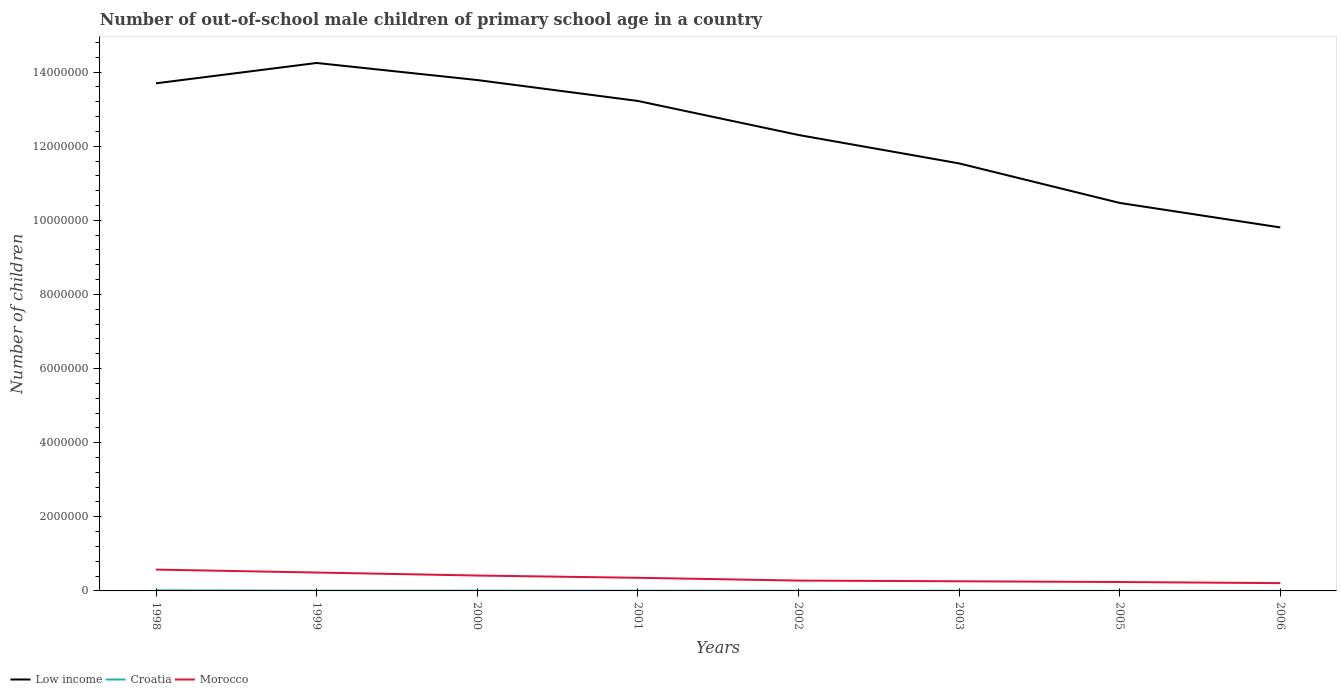How many different coloured lines are there?
Make the answer very short. 3. Does the line corresponding to Croatia intersect with the line corresponding to Low income?
Provide a succinct answer. No. Is the number of lines equal to the number of legend labels?
Offer a terse response. Yes. Across all years, what is the maximum number of out-of-school male children in Croatia?
Provide a short and direct response. 1613. In which year was the number of out-of-school male children in Low income maximum?
Your answer should be compact. 2006. What is the total number of out-of-school male children in Croatia in the graph?
Offer a terse response. 1.18e+04. What is the difference between the highest and the second highest number of out-of-school male children in Morocco?
Your answer should be very brief. 3.65e+05. Is the number of out-of-school male children in Low income strictly greater than the number of out-of-school male children in Croatia over the years?
Offer a terse response. No. How many lines are there?
Your answer should be very brief. 3. How many legend labels are there?
Provide a succinct answer. 3. What is the title of the graph?
Offer a terse response. Number of out-of-school male children of primary school age in a country. What is the label or title of the Y-axis?
Provide a short and direct response. Number of children. What is the Number of children of Low income in 1998?
Keep it short and to the point. 1.37e+07. What is the Number of children of Croatia in 1998?
Offer a very short reply. 1.62e+04. What is the Number of children of Morocco in 1998?
Keep it short and to the point. 5.76e+05. What is the Number of children of Low income in 1999?
Offer a terse response. 1.42e+07. What is the Number of children of Croatia in 1999?
Your answer should be compact. 6765. What is the Number of children in Morocco in 1999?
Offer a very short reply. 4.96e+05. What is the Number of children of Low income in 2000?
Ensure brevity in your answer.  1.38e+07. What is the Number of children of Croatia in 2000?
Give a very brief answer. 6522. What is the Number of children of Morocco in 2000?
Offer a terse response. 4.15e+05. What is the Number of children in Low income in 2001?
Provide a short and direct response. 1.32e+07. What is the Number of children of Croatia in 2001?
Keep it short and to the point. 5639. What is the Number of children in Morocco in 2001?
Ensure brevity in your answer.  3.54e+05. What is the Number of children in Low income in 2002?
Provide a succinct answer. 1.23e+07. What is the Number of children in Croatia in 2002?
Offer a very short reply. 4458. What is the Number of children of Morocco in 2002?
Your answer should be very brief. 2.79e+05. What is the Number of children in Low income in 2003?
Keep it short and to the point. 1.15e+07. What is the Number of children in Croatia in 2003?
Offer a terse response. 3994. What is the Number of children in Morocco in 2003?
Offer a terse response. 2.60e+05. What is the Number of children in Low income in 2005?
Keep it short and to the point. 1.05e+07. What is the Number of children of Croatia in 2005?
Your answer should be very brief. 1768. What is the Number of children of Morocco in 2005?
Ensure brevity in your answer.  2.41e+05. What is the Number of children in Low income in 2006?
Ensure brevity in your answer.  9.81e+06. What is the Number of children of Croatia in 2006?
Give a very brief answer. 1613. What is the Number of children in Morocco in 2006?
Keep it short and to the point. 2.10e+05. Across all years, what is the maximum Number of children in Low income?
Ensure brevity in your answer.  1.42e+07. Across all years, what is the maximum Number of children in Croatia?
Give a very brief answer. 1.62e+04. Across all years, what is the maximum Number of children of Morocco?
Make the answer very short. 5.76e+05. Across all years, what is the minimum Number of children of Low income?
Ensure brevity in your answer.  9.81e+06. Across all years, what is the minimum Number of children of Croatia?
Make the answer very short. 1613. Across all years, what is the minimum Number of children in Morocco?
Give a very brief answer. 2.10e+05. What is the total Number of children of Low income in the graph?
Offer a terse response. 9.91e+07. What is the total Number of children in Croatia in the graph?
Offer a terse response. 4.70e+04. What is the total Number of children of Morocco in the graph?
Provide a succinct answer. 2.83e+06. What is the difference between the Number of children in Low income in 1998 and that in 1999?
Give a very brief answer. -5.49e+05. What is the difference between the Number of children of Croatia in 1998 and that in 1999?
Your answer should be very brief. 9472. What is the difference between the Number of children of Morocco in 1998 and that in 1999?
Make the answer very short. 7.91e+04. What is the difference between the Number of children in Low income in 1998 and that in 2000?
Ensure brevity in your answer.  -8.84e+04. What is the difference between the Number of children of Croatia in 1998 and that in 2000?
Your answer should be very brief. 9715. What is the difference between the Number of children of Morocco in 1998 and that in 2000?
Provide a short and direct response. 1.60e+05. What is the difference between the Number of children of Low income in 1998 and that in 2001?
Give a very brief answer. 4.76e+05. What is the difference between the Number of children of Croatia in 1998 and that in 2001?
Offer a terse response. 1.06e+04. What is the difference between the Number of children in Morocco in 1998 and that in 2001?
Your answer should be very brief. 2.22e+05. What is the difference between the Number of children of Low income in 1998 and that in 2002?
Give a very brief answer. 1.39e+06. What is the difference between the Number of children in Croatia in 1998 and that in 2002?
Ensure brevity in your answer.  1.18e+04. What is the difference between the Number of children of Morocco in 1998 and that in 2002?
Give a very brief answer. 2.96e+05. What is the difference between the Number of children of Low income in 1998 and that in 2003?
Provide a short and direct response. 2.16e+06. What is the difference between the Number of children of Croatia in 1998 and that in 2003?
Your response must be concise. 1.22e+04. What is the difference between the Number of children in Morocco in 1998 and that in 2003?
Offer a very short reply. 3.16e+05. What is the difference between the Number of children in Low income in 1998 and that in 2005?
Provide a succinct answer. 3.23e+06. What is the difference between the Number of children of Croatia in 1998 and that in 2005?
Offer a terse response. 1.45e+04. What is the difference between the Number of children in Morocco in 1998 and that in 2005?
Provide a short and direct response. 3.35e+05. What is the difference between the Number of children of Low income in 1998 and that in 2006?
Your answer should be very brief. 3.89e+06. What is the difference between the Number of children of Croatia in 1998 and that in 2006?
Make the answer very short. 1.46e+04. What is the difference between the Number of children of Morocco in 1998 and that in 2006?
Keep it short and to the point. 3.65e+05. What is the difference between the Number of children in Low income in 1999 and that in 2000?
Keep it short and to the point. 4.61e+05. What is the difference between the Number of children of Croatia in 1999 and that in 2000?
Make the answer very short. 243. What is the difference between the Number of children of Morocco in 1999 and that in 2000?
Ensure brevity in your answer.  8.11e+04. What is the difference between the Number of children of Low income in 1999 and that in 2001?
Your answer should be very brief. 1.02e+06. What is the difference between the Number of children in Croatia in 1999 and that in 2001?
Keep it short and to the point. 1126. What is the difference between the Number of children in Morocco in 1999 and that in 2001?
Ensure brevity in your answer.  1.42e+05. What is the difference between the Number of children in Low income in 1999 and that in 2002?
Offer a terse response. 1.94e+06. What is the difference between the Number of children in Croatia in 1999 and that in 2002?
Offer a terse response. 2307. What is the difference between the Number of children of Morocco in 1999 and that in 2002?
Provide a succinct answer. 2.17e+05. What is the difference between the Number of children in Low income in 1999 and that in 2003?
Your response must be concise. 2.71e+06. What is the difference between the Number of children of Croatia in 1999 and that in 2003?
Your response must be concise. 2771. What is the difference between the Number of children in Morocco in 1999 and that in 2003?
Give a very brief answer. 2.36e+05. What is the difference between the Number of children of Low income in 1999 and that in 2005?
Offer a very short reply. 3.78e+06. What is the difference between the Number of children of Croatia in 1999 and that in 2005?
Offer a very short reply. 4997. What is the difference between the Number of children in Morocco in 1999 and that in 2005?
Offer a very short reply. 2.56e+05. What is the difference between the Number of children in Low income in 1999 and that in 2006?
Your answer should be very brief. 4.44e+06. What is the difference between the Number of children of Croatia in 1999 and that in 2006?
Give a very brief answer. 5152. What is the difference between the Number of children in Morocco in 1999 and that in 2006?
Provide a short and direct response. 2.86e+05. What is the difference between the Number of children of Low income in 2000 and that in 2001?
Give a very brief answer. 5.64e+05. What is the difference between the Number of children in Croatia in 2000 and that in 2001?
Provide a succinct answer. 883. What is the difference between the Number of children of Morocco in 2000 and that in 2001?
Your response must be concise. 6.14e+04. What is the difference between the Number of children in Low income in 2000 and that in 2002?
Your response must be concise. 1.48e+06. What is the difference between the Number of children in Croatia in 2000 and that in 2002?
Give a very brief answer. 2064. What is the difference between the Number of children in Morocco in 2000 and that in 2002?
Your response must be concise. 1.36e+05. What is the difference between the Number of children in Low income in 2000 and that in 2003?
Make the answer very short. 2.25e+06. What is the difference between the Number of children of Croatia in 2000 and that in 2003?
Offer a terse response. 2528. What is the difference between the Number of children in Morocco in 2000 and that in 2003?
Provide a short and direct response. 1.55e+05. What is the difference between the Number of children of Low income in 2000 and that in 2005?
Make the answer very short. 3.32e+06. What is the difference between the Number of children of Croatia in 2000 and that in 2005?
Ensure brevity in your answer.  4754. What is the difference between the Number of children of Morocco in 2000 and that in 2005?
Your answer should be very brief. 1.75e+05. What is the difference between the Number of children in Low income in 2000 and that in 2006?
Make the answer very short. 3.98e+06. What is the difference between the Number of children in Croatia in 2000 and that in 2006?
Provide a succinct answer. 4909. What is the difference between the Number of children in Morocco in 2000 and that in 2006?
Provide a short and direct response. 2.05e+05. What is the difference between the Number of children of Low income in 2001 and that in 2002?
Provide a short and direct response. 9.18e+05. What is the difference between the Number of children of Croatia in 2001 and that in 2002?
Your response must be concise. 1181. What is the difference between the Number of children of Morocco in 2001 and that in 2002?
Provide a short and direct response. 7.48e+04. What is the difference between the Number of children of Low income in 2001 and that in 2003?
Your response must be concise. 1.69e+06. What is the difference between the Number of children in Croatia in 2001 and that in 2003?
Provide a succinct answer. 1645. What is the difference between the Number of children of Morocco in 2001 and that in 2003?
Your response must be concise. 9.40e+04. What is the difference between the Number of children of Low income in 2001 and that in 2005?
Keep it short and to the point. 2.75e+06. What is the difference between the Number of children of Croatia in 2001 and that in 2005?
Provide a short and direct response. 3871. What is the difference between the Number of children in Morocco in 2001 and that in 2005?
Offer a terse response. 1.13e+05. What is the difference between the Number of children in Low income in 2001 and that in 2006?
Provide a short and direct response. 3.41e+06. What is the difference between the Number of children in Croatia in 2001 and that in 2006?
Your answer should be compact. 4026. What is the difference between the Number of children in Morocco in 2001 and that in 2006?
Ensure brevity in your answer.  1.44e+05. What is the difference between the Number of children of Low income in 2002 and that in 2003?
Ensure brevity in your answer.  7.67e+05. What is the difference between the Number of children in Croatia in 2002 and that in 2003?
Your answer should be very brief. 464. What is the difference between the Number of children in Morocco in 2002 and that in 2003?
Ensure brevity in your answer.  1.92e+04. What is the difference between the Number of children in Low income in 2002 and that in 2005?
Your answer should be compact. 1.83e+06. What is the difference between the Number of children of Croatia in 2002 and that in 2005?
Provide a short and direct response. 2690. What is the difference between the Number of children of Morocco in 2002 and that in 2005?
Your answer should be very brief. 3.86e+04. What is the difference between the Number of children in Low income in 2002 and that in 2006?
Your answer should be very brief. 2.50e+06. What is the difference between the Number of children of Croatia in 2002 and that in 2006?
Your response must be concise. 2845. What is the difference between the Number of children of Morocco in 2002 and that in 2006?
Give a very brief answer. 6.87e+04. What is the difference between the Number of children in Low income in 2003 and that in 2005?
Keep it short and to the point. 1.07e+06. What is the difference between the Number of children in Croatia in 2003 and that in 2005?
Give a very brief answer. 2226. What is the difference between the Number of children of Morocco in 2003 and that in 2005?
Provide a succinct answer. 1.94e+04. What is the difference between the Number of children in Low income in 2003 and that in 2006?
Offer a terse response. 1.73e+06. What is the difference between the Number of children of Croatia in 2003 and that in 2006?
Your answer should be very brief. 2381. What is the difference between the Number of children in Morocco in 2003 and that in 2006?
Make the answer very short. 4.95e+04. What is the difference between the Number of children in Low income in 2005 and that in 2006?
Your answer should be compact. 6.61e+05. What is the difference between the Number of children of Croatia in 2005 and that in 2006?
Provide a succinct answer. 155. What is the difference between the Number of children in Morocco in 2005 and that in 2006?
Give a very brief answer. 3.01e+04. What is the difference between the Number of children of Low income in 1998 and the Number of children of Croatia in 1999?
Give a very brief answer. 1.37e+07. What is the difference between the Number of children in Low income in 1998 and the Number of children in Morocco in 1999?
Provide a short and direct response. 1.32e+07. What is the difference between the Number of children in Croatia in 1998 and the Number of children in Morocco in 1999?
Ensure brevity in your answer.  -4.80e+05. What is the difference between the Number of children of Low income in 1998 and the Number of children of Croatia in 2000?
Offer a very short reply. 1.37e+07. What is the difference between the Number of children in Low income in 1998 and the Number of children in Morocco in 2000?
Provide a succinct answer. 1.33e+07. What is the difference between the Number of children in Croatia in 1998 and the Number of children in Morocco in 2000?
Offer a terse response. -3.99e+05. What is the difference between the Number of children of Low income in 1998 and the Number of children of Croatia in 2001?
Ensure brevity in your answer.  1.37e+07. What is the difference between the Number of children in Low income in 1998 and the Number of children in Morocco in 2001?
Offer a very short reply. 1.33e+07. What is the difference between the Number of children in Croatia in 1998 and the Number of children in Morocco in 2001?
Give a very brief answer. -3.38e+05. What is the difference between the Number of children in Low income in 1998 and the Number of children in Croatia in 2002?
Offer a very short reply. 1.37e+07. What is the difference between the Number of children in Low income in 1998 and the Number of children in Morocco in 2002?
Your answer should be compact. 1.34e+07. What is the difference between the Number of children in Croatia in 1998 and the Number of children in Morocco in 2002?
Your answer should be very brief. -2.63e+05. What is the difference between the Number of children in Low income in 1998 and the Number of children in Croatia in 2003?
Your response must be concise. 1.37e+07. What is the difference between the Number of children of Low income in 1998 and the Number of children of Morocco in 2003?
Your answer should be very brief. 1.34e+07. What is the difference between the Number of children of Croatia in 1998 and the Number of children of Morocco in 2003?
Offer a terse response. -2.44e+05. What is the difference between the Number of children of Low income in 1998 and the Number of children of Croatia in 2005?
Offer a very short reply. 1.37e+07. What is the difference between the Number of children of Low income in 1998 and the Number of children of Morocco in 2005?
Offer a very short reply. 1.35e+07. What is the difference between the Number of children in Croatia in 1998 and the Number of children in Morocco in 2005?
Ensure brevity in your answer.  -2.24e+05. What is the difference between the Number of children of Low income in 1998 and the Number of children of Croatia in 2006?
Give a very brief answer. 1.37e+07. What is the difference between the Number of children of Low income in 1998 and the Number of children of Morocco in 2006?
Ensure brevity in your answer.  1.35e+07. What is the difference between the Number of children in Croatia in 1998 and the Number of children in Morocco in 2006?
Give a very brief answer. -1.94e+05. What is the difference between the Number of children in Low income in 1999 and the Number of children in Croatia in 2000?
Give a very brief answer. 1.42e+07. What is the difference between the Number of children in Low income in 1999 and the Number of children in Morocco in 2000?
Provide a succinct answer. 1.38e+07. What is the difference between the Number of children of Croatia in 1999 and the Number of children of Morocco in 2000?
Give a very brief answer. -4.09e+05. What is the difference between the Number of children in Low income in 1999 and the Number of children in Croatia in 2001?
Offer a terse response. 1.42e+07. What is the difference between the Number of children of Low income in 1999 and the Number of children of Morocco in 2001?
Ensure brevity in your answer.  1.39e+07. What is the difference between the Number of children in Croatia in 1999 and the Number of children in Morocco in 2001?
Give a very brief answer. -3.47e+05. What is the difference between the Number of children in Low income in 1999 and the Number of children in Croatia in 2002?
Your answer should be compact. 1.42e+07. What is the difference between the Number of children in Low income in 1999 and the Number of children in Morocco in 2002?
Ensure brevity in your answer.  1.40e+07. What is the difference between the Number of children of Croatia in 1999 and the Number of children of Morocco in 2002?
Keep it short and to the point. -2.72e+05. What is the difference between the Number of children of Low income in 1999 and the Number of children of Croatia in 2003?
Your response must be concise. 1.42e+07. What is the difference between the Number of children in Low income in 1999 and the Number of children in Morocco in 2003?
Give a very brief answer. 1.40e+07. What is the difference between the Number of children in Croatia in 1999 and the Number of children in Morocco in 2003?
Your response must be concise. -2.53e+05. What is the difference between the Number of children in Low income in 1999 and the Number of children in Croatia in 2005?
Make the answer very short. 1.42e+07. What is the difference between the Number of children of Low income in 1999 and the Number of children of Morocco in 2005?
Provide a short and direct response. 1.40e+07. What is the difference between the Number of children of Croatia in 1999 and the Number of children of Morocco in 2005?
Your response must be concise. -2.34e+05. What is the difference between the Number of children in Low income in 1999 and the Number of children in Croatia in 2006?
Make the answer very short. 1.42e+07. What is the difference between the Number of children of Low income in 1999 and the Number of children of Morocco in 2006?
Provide a succinct answer. 1.40e+07. What is the difference between the Number of children of Croatia in 1999 and the Number of children of Morocco in 2006?
Your answer should be compact. -2.04e+05. What is the difference between the Number of children of Low income in 2000 and the Number of children of Croatia in 2001?
Make the answer very short. 1.38e+07. What is the difference between the Number of children in Low income in 2000 and the Number of children in Morocco in 2001?
Ensure brevity in your answer.  1.34e+07. What is the difference between the Number of children of Croatia in 2000 and the Number of children of Morocco in 2001?
Make the answer very short. -3.47e+05. What is the difference between the Number of children of Low income in 2000 and the Number of children of Croatia in 2002?
Make the answer very short. 1.38e+07. What is the difference between the Number of children in Low income in 2000 and the Number of children in Morocco in 2002?
Give a very brief answer. 1.35e+07. What is the difference between the Number of children of Croatia in 2000 and the Number of children of Morocco in 2002?
Offer a terse response. -2.73e+05. What is the difference between the Number of children in Low income in 2000 and the Number of children in Croatia in 2003?
Provide a short and direct response. 1.38e+07. What is the difference between the Number of children of Low income in 2000 and the Number of children of Morocco in 2003?
Make the answer very short. 1.35e+07. What is the difference between the Number of children in Croatia in 2000 and the Number of children in Morocco in 2003?
Provide a succinct answer. -2.53e+05. What is the difference between the Number of children in Low income in 2000 and the Number of children in Croatia in 2005?
Offer a terse response. 1.38e+07. What is the difference between the Number of children in Low income in 2000 and the Number of children in Morocco in 2005?
Make the answer very short. 1.35e+07. What is the difference between the Number of children of Croatia in 2000 and the Number of children of Morocco in 2005?
Keep it short and to the point. -2.34e+05. What is the difference between the Number of children in Low income in 2000 and the Number of children in Croatia in 2006?
Provide a short and direct response. 1.38e+07. What is the difference between the Number of children in Low income in 2000 and the Number of children in Morocco in 2006?
Offer a terse response. 1.36e+07. What is the difference between the Number of children of Croatia in 2000 and the Number of children of Morocco in 2006?
Your answer should be compact. -2.04e+05. What is the difference between the Number of children of Low income in 2001 and the Number of children of Croatia in 2002?
Offer a terse response. 1.32e+07. What is the difference between the Number of children in Low income in 2001 and the Number of children in Morocco in 2002?
Offer a very short reply. 1.29e+07. What is the difference between the Number of children of Croatia in 2001 and the Number of children of Morocco in 2002?
Provide a short and direct response. -2.74e+05. What is the difference between the Number of children of Low income in 2001 and the Number of children of Croatia in 2003?
Your response must be concise. 1.32e+07. What is the difference between the Number of children of Low income in 2001 and the Number of children of Morocco in 2003?
Your answer should be very brief. 1.30e+07. What is the difference between the Number of children in Croatia in 2001 and the Number of children in Morocco in 2003?
Offer a very short reply. -2.54e+05. What is the difference between the Number of children in Low income in 2001 and the Number of children in Croatia in 2005?
Give a very brief answer. 1.32e+07. What is the difference between the Number of children of Low income in 2001 and the Number of children of Morocco in 2005?
Make the answer very short. 1.30e+07. What is the difference between the Number of children in Croatia in 2001 and the Number of children in Morocco in 2005?
Provide a short and direct response. -2.35e+05. What is the difference between the Number of children in Low income in 2001 and the Number of children in Croatia in 2006?
Your response must be concise. 1.32e+07. What is the difference between the Number of children in Low income in 2001 and the Number of children in Morocco in 2006?
Your response must be concise. 1.30e+07. What is the difference between the Number of children of Croatia in 2001 and the Number of children of Morocco in 2006?
Your answer should be very brief. -2.05e+05. What is the difference between the Number of children of Low income in 2002 and the Number of children of Croatia in 2003?
Offer a very short reply. 1.23e+07. What is the difference between the Number of children of Low income in 2002 and the Number of children of Morocco in 2003?
Offer a very short reply. 1.20e+07. What is the difference between the Number of children in Croatia in 2002 and the Number of children in Morocco in 2003?
Offer a very short reply. -2.55e+05. What is the difference between the Number of children of Low income in 2002 and the Number of children of Croatia in 2005?
Give a very brief answer. 1.23e+07. What is the difference between the Number of children of Low income in 2002 and the Number of children of Morocco in 2005?
Give a very brief answer. 1.21e+07. What is the difference between the Number of children of Croatia in 2002 and the Number of children of Morocco in 2005?
Your response must be concise. -2.36e+05. What is the difference between the Number of children in Low income in 2002 and the Number of children in Croatia in 2006?
Keep it short and to the point. 1.23e+07. What is the difference between the Number of children in Low income in 2002 and the Number of children in Morocco in 2006?
Provide a succinct answer. 1.21e+07. What is the difference between the Number of children of Croatia in 2002 and the Number of children of Morocco in 2006?
Your answer should be compact. -2.06e+05. What is the difference between the Number of children of Low income in 2003 and the Number of children of Croatia in 2005?
Your response must be concise. 1.15e+07. What is the difference between the Number of children in Low income in 2003 and the Number of children in Morocco in 2005?
Your answer should be compact. 1.13e+07. What is the difference between the Number of children in Croatia in 2003 and the Number of children in Morocco in 2005?
Provide a short and direct response. -2.37e+05. What is the difference between the Number of children in Low income in 2003 and the Number of children in Croatia in 2006?
Offer a very short reply. 1.15e+07. What is the difference between the Number of children in Low income in 2003 and the Number of children in Morocco in 2006?
Offer a terse response. 1.13e+07. What is the difference between the Number of children of Croatia in 2003 and the Number of children of Morocco in 2006?
Provide a succinct answer. -2.06e+05. What is the difference between the Number of children of Low income in 2005 and the Number of children of Croatia in 2006?
Your answer should be compact. 1.05e+07. What is the difference between the Number of children in Low income in 2005 and the Number of children in Morocco in 2006?
Keep it short and to the point. 1.03e+07. What is the difference between the Number of children in Croatia in 2005 and the Number of children in Morocco in 2006?
Your answer should be compact. -2.09e+05. What is the average Number of children of Low income per year?
Offer a very short reply. 1.24e+07. What is the average Number of children of Croatia per year?
Your answer should be very brief. 5874.5. What is the average Number of children of Morocco per year?
Offer a very short reply. 3.54e+05. In the year 1998, what is the difference between the Number of children of Low income and Number of children of Croatia?
Offer a very short reply. 1.37e+07. In the year 1998, what is the difference between the Number of children of Low income and Number of children of Morocco?
Ensure brevity in your answer.  1.31e+07. In the year 1998, what is the difference between the Number of children of Croatia and Number of children of Morocco?
Your answer should be very brief. -5.59e+05. In the year 1999, what is the difference between the Number of children of Low income and Number of children of Croatia?
Make the answer very short. 1.42e+07. In the year 1999, what is the difference between the Number of children in Low income and Number of children in Morocco?
Your answer should be very brief. 1.38e+07. In the year 1999, what is the difference between the Number of children of Croatia and Number of children of Morocco?
Give a very brief answer. -4.90e+05. In the year 2000, what is the difference between the Number of children in Low income and Number of children in Croatia?
Offer a terse response. 1.38e+07. In the year 2000, what is the difference between the Number of children in Low income and Number of children in Morocco?
Make the answer very short. 1.34e+07. In the year 2000, what is the difference between the Number of children in Croatia and Number of children in Morocco?
Provide a succinct answer. -4.09e+05. In the year 2001, what is the difference between the Number of children in Low income and Number of children in Croatia?
Your answer should be very brief. 1.32e+07. In the year 2001, what is the difference between the Number of children of Low income and Number of children of Morocco?
Provide a succinct answer. 1.29e+07. In the year 2001, what is the difference between the Number of children in Croatia and Number of children in Morocco?
Your answer should be very brief. -3.48e+05. In the year 2002, what is the difference between the Number of children of Low income and Number of children of Croatia?
Keep it short and to the point. 1.23e+07. In the year 2002, what is the difference between the Number of children of Low income and Number of children of Morocco?
Your response must be concise. 1.20e+07. In the year 2002, what is the difference between the Number of children of Croatia and Number of children of Morocco?
Give a very brief answer. -2.75e+05. In the year 2003, what is the difference between the Number of children of Low income and Number of children of Croatia?
Give a very brief answer. 1.15e+07. In the year 2003, what is the difference between the Number of children in Low income and Number of children in Morocco?
Make the answer very short. 1.13e+07. In the year 2003, what is the difference between the Number of children of Croatia and Number of children of Morocco?
Keep it short and to the point. -2.56e+05. In the year 2005, what is the difference between the Number of children of Low income and Number of children of Croatia?
Make the answer very short. 1.05e+07. In the year 2005, what is the difference between the Number of children in Low income and Number of children in Morocco?
Ensure brevity in your answer.  1.02e+07. In the year 2005, what is the difference between the Number of children of Croatia and Number of children of Morocco?
Your answer should be compact. -2.39e+05. In the year 2006, what is the difference between the Number of children of Low income and Number of children of Croatia?
Your answer should be very brief. 9.81e+06. In the year 2006, what is the difference between the Number of children of Low income and Number of children of Morocco?
Offer a very short reply. 9.60e+06. In the year 2006, what is the difference between the Number of children of Croatia and Number of children of Morocco?
Provide a short and direct response. -2.09e+05. What is the ratio of the Number of children of Low income in 1998 to that in 1999?
Your answer should be very brief. 0.96. What is the ratio of the Number of children in Croatia in 1998 to that in 1999?
Keep it short and to the point. 2.4. What is the ratio of the Number of children of Morocco in 1998 to that in 1999?
Provide a short and direct response. 1.16. What is the ratio of the Number of children of Croatia in 1998 to that in 2000?
Provide a short and direct response. 2.49. What is the ratio of the Number of children in Morocco in 1998 to that in 2000?
Your answer should be very brief. 1.39. What is the ratio of the Number of children in Low income in 1998 to that in 2001?
Your answer should be very brief. 1.04. What is the ratio of the Number of children of Croatia in 1998 to that in 2001?
Give a very brief answer. 2.88. What is the ratio of the Number of children of Morocco in 1998 to that in 2001?
Provide a succinct answer. 1.63. What is the ratio of the Number of children of Low income in 1998 to that in 2002?
Your answer should be compact. 1.11. What is the ratio of the Number of children in Croatia in 1998 to that in 2002?
Provide a succinct answer. 3.64. What is the ratio of the Number of children of Morocco in 1998 to that in 2002?
Your answer should be compact. 2.06. What is the ratio of the Number of children in Low income in 1998 to that in 2003?
Give a very brief answer. 1.19. What is the ratio of the Number of children of Croatia in 1998 to that in 2003?
Provide a succinct answer. 4.07. What is the ratio of the Number of children of Morocco in 1998 to that in 2003?
Keep it short and to the point. 2.21. What is the ratio of the Number of children in Low income in 1998 to that in 2005?
Make the answer very short. 1.31. What is the ratio of the Number of children in Croatia in 1998 to that in 2005?
Keep it short and to the point. 9.18. What is the ratio of the Number of children of Morocco in 1998 to that in 2005?
Your answer should be compact. 2.39. What is the ratio of the Number of children in Low income in 1998 to that in 2006?
Your response must be concise. 1.4. What is the ratio of the Number of children in Croatia in 1998 to that in 2006?
Provide a succinct answer. 10.07. What is the ratio of the Number of children in Morocco in 1998 to that in 2006?
Provide a short and direct response. 2.73. What is the ratio of the Number of children in Low income in 1999 to that in 2000?
Your answer should be compact. 1.03. What is the ratio of the Number of children of Croatia in 1999 to that in 2000?
Your answer should be very brief. 1.04. What is the ratio of the Number of children of Morocco in 1999 to that in 2000?
Offer a very short reply. 1.2. What is the ratio of the Number of children in Low income in 1999 to that in 2001?
Provide a short and direct response. 1.08. What is the ratio of the Number of children in Croatia in 1999 to that in 2001?
Your response must be concise. 1.2. What is the ratio of the Number of children of Morocco in 1999 to that in 2001?
Make the answer very short. 1.4. What is the ratio of the Number of children in Low income in 1999 to that in 2002?
Provide a succinct answer. 1.16. What is the ratio of the Number of children in Croatia in 1999 to that in 2002?
Provide a succinct answer. 1.52. What is the ratio of the Number of children in Morocco in 1999 to that in 2002?
Your response must be concise. 1.78. What is the ratio of the Number of children of Low income in 1999 to that in 2003?
Your answer should be very brief. 1.23. What is the ratio of the Number of children in Croatia in 1999 to that in 2003?
Your answer should be very brief. 1.69. What is the ratio of the Number of children of Morocco in 1999 to that in 2003?
Offer a very short reply. 1.91. What is the ratio of the Number of children in Low income in 1999 to that in 2005?
Provide a short and direct response. 1.36. What is the ratio of the Number of children of Croatia in 1999 to that in 2005?
Give a very brief answer. 3.83. What is the ratio of the Number of children in Morocco in 1999 to that in 2005?
Keep it short and to the point. 2.06. What is the ratio of the Number of children of Low income in 1999 to that in 2006?
Your answer should be very brief. 1.45. What is the ratio of the Number of children of Croatia in 1999 to that in 2006?
Keep it short and to the point. 4.19. What is the ratio of the Number of children in Morocco in 1999 to that in 2006?
Offer a very short reply. 2.36. What is the ratio of the Number of children of Low income in 2000 to that in 2001?
Keep it short and to the point. 1.04. What is the ratio of the Number of children in Croatia in 2000 to that in 2001?
Make the answer very short. 1.16. What is the ratio of the Number of children in Morocco in 2000 to that in 2001?
Keep it short and to the point. 1.17. What is the ratio of the Number of children of Low income in 2000 to that in 2002?
Give a very brief answer. 1.12. What is the ratio of the Number of children of Croatia in 2000 to that in 2002?
Provide a short and direct response. 1.46. What is the ratio of the Number of children in Morocco in 2000 to that in 2002?
Your response must be concise. 1.49. What is the ratio of the Number of children of Low income in 2000 to that in 2003?
Your response must be concise. 1.2. What is the ratio of the Number of children of Croatia in 2000 to that in 2003?
Provide a short and direct response. 1.63. What is the ratio of the Number of children of Morocco in 2000 to that in 2003?
Your response must be concise. 1.6. What is the ratio of the Number of children in Low income in 2000 to that in 2005?
Your response must be concise. 1.32. What is the ratio of the Number of children of Croatia in 2000 to that in 2005?
Make the answer very short. 3.69. What is the ratio of the Number of children of Morocco in 2000 to that in 2005?
Your answer should be compact. 1.73. What is the ratio of the Number of children of Low income in 2000 to that in 2006?
Give a very brief answer. 1.41. What is the ratio of the Number of children in Croatia in 2000 to that in 2006?
Provide a succinct answer. 4.04. What is the ratio of the Number of children of Morocco in 2000 to that in 2006?
Make the answer very short. 1.97. What is the ratio of the Number of children of Low income in 2001 to that in 2002?
Ensure brevity in your answer.  1.07. What is the ratio of the Number of children in Croatia in 2001 to that in 2002?
Your answer should be compact. 1.26. What is the ratio of the Number of children of Morocco in 2001 to that in 2002?
Make the answer very short. 1.27. What is the ratio of the Number of children in Low income in 2001 to that in 2003?
Give a very brief answer. 1.15. What is the ratio of the Number of children of Croatia in 2001 to that in 2003?
Ensure brevity in your answer.  1.41. What is the ratio of the Number of children in Morocco in 2001 to that in 2003?
Provide a short and direct response. 1.36. What is the ratio of the Number of children of Low income in 2001 to that in 2005?
Your response must be concise. 1.26. What is the ratio of the Number of children of Croatia in 2001 to that in 2005?
Offer a terse response. 3.19. What is the ratio of the Number of children in Morocco in 2001 to that in 2005?
Your answer should be very brief. 1.47. What is the ratio of the Number of children of Low income in 2001 to that in 2006?
Make the answer very short. 1.35. What is the ratio of the Number of children of Croatia in 2001 to that in 2006?
Your answer should be compact. 3.5. What is the ratio of the Number of children in Morocco in 2001 to that in 2006?
Make the answer very short. 1.68. What is the ratio of the Number of children in Low income in 2002 to that in 2003?
Ensure brevity in your answer.  1.07. What is the ratio of the Number of children of Croatia in 2002 to that in 2003?
Make the answer very short. 1.12. What is the ratio of the Number of children in Morocco in 2002 to that in 2003?
Give a very brief answer. 1.07. What is the ratio of the Number of children in Low income in 2002 to that in 2005?
Keep it short and to the point. 1.18. What is the ratio of the Number of children of Croatia in 2002 to that in 2005?
Provide a succinct answer. 2.52. What is the ratio of the Number of children of Morocco in 2002 to that in 2005?
Offer a very short reply. 1.16. What is the ratio of the Number of children of Low income in 2002 to that in 2006?
Ensure brevity in your answer.  1.25. What is the ratio of the Number of children in Croatia in 2002 to that in 2006?
Offer a very short reply. 2.76. What is the ratio of the Number of children of Morocco in 2002 to that in 2006?
Provide a short and direct response. 1.33. What is the ratio of the Number of children of Low income in 2003 to that in 2005?
Your answer should be compact. 1.1. What is the ratio of the Number of children in Croatia in 2003 to that in 2005?
Ensure brevity in your answer.  2.26. What is the ratio of the Number of children in Morocco in 2003 to that in 2005?
Your answer should be compact. 1.08. What is the ratio of the Number of children in Low income in 2003 to that in 2006?
Offer a very short reply. 1.18. What is the ratio of the Number of children in Croatia in 2003 to that in 2006?
Ensure brevity in your answer.  2.48. What is the ratio of the Number of children of Morocco in 2003 to that in 2006?
Offer a very short reply. 1.24. What is the ratio of the Number of children in Low income in 2005 to that in 2006?
Your response must be concise. 1.07. What is the ratio of the Number of children of Croatia in 2005 to that in 2006?
Provide a succinct answer. 1.1. What is the ratio of the Number of children of Morocco in 2005 to that in 2006?
Make the answer very short. 1.14. What is the difference between the highest and the second highest Number of children of Low income?
Your answer should be very brief. 4.61e+05. What is the difference between the highest and the second highest Number of children of Croatia?
Your answer should be compact. 9472. What is the difference between the highest and the second highest Number of children of Morocco?
Offer a very short reply. 7.91e+04. What is the difference between the highest and the lowest Number of children of Low income?
Make the answer very short. 4.44e+06. What is the difference between the highest and the lowest Number of children of Croatia?
Your answer should be compact. 1.46e+04. What is the difference between the highest and the lowest Number of children in Morocco?
Your answer should be very brief. 3.65e+05. 